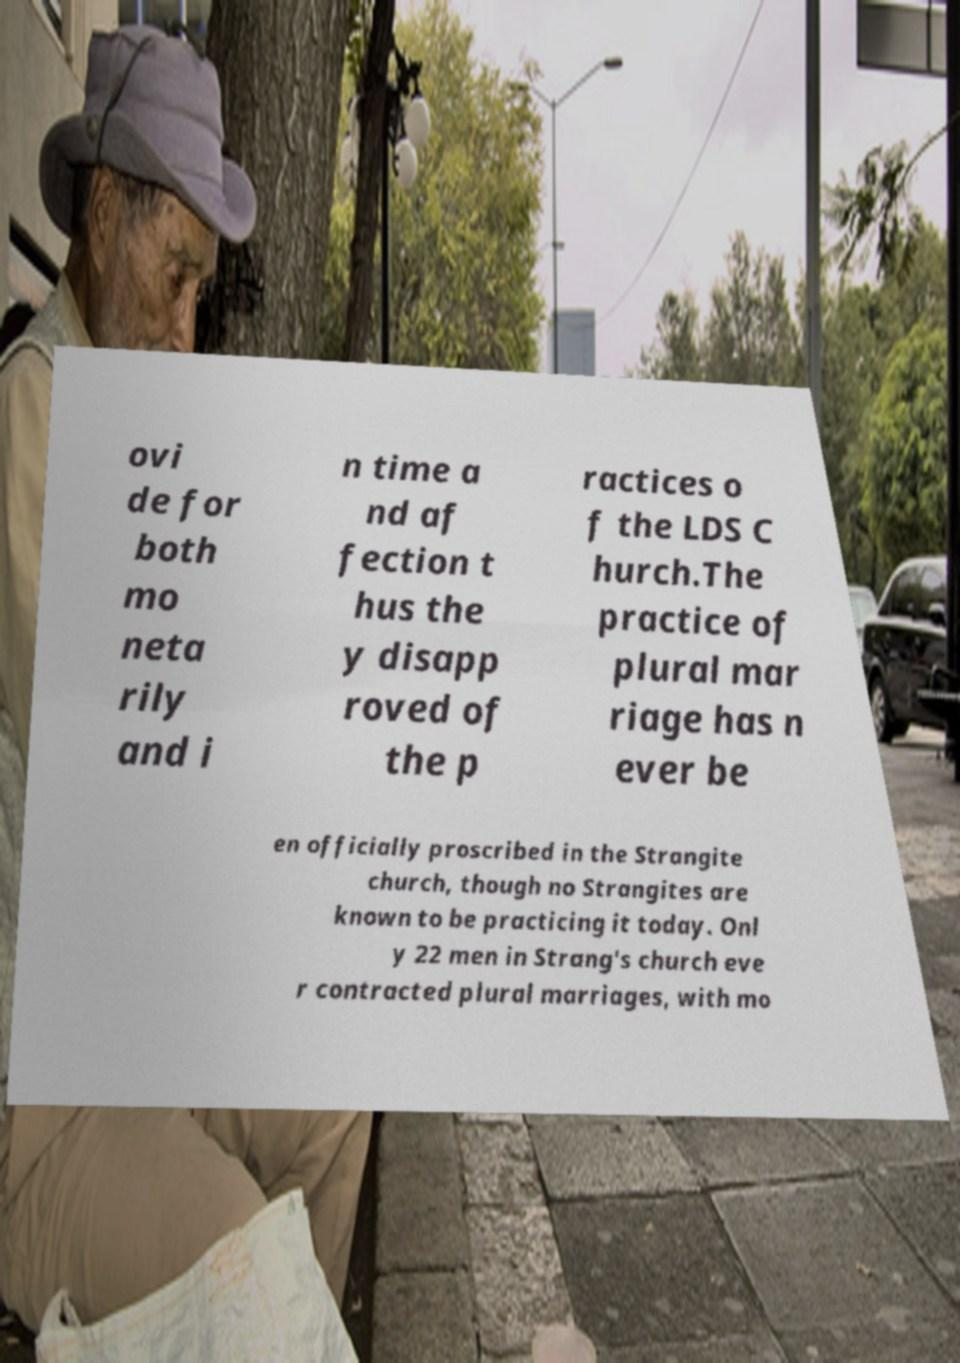Can you read and provide the text displayed in the image?This photo seems to have some interesting text. Can you extract and type it out for me? ovi de for both mo neta rily and i n time a nd af fection t hus the y disapp roved of the p ractices o f the LDS C hurch.The practice of plural mar riage has n ever be en officially proscribed in the Strangite church, though no Strangites are known to be practicing it today. Onl y 22 men in Strang's church eve r contracted plural marriages, with mo 